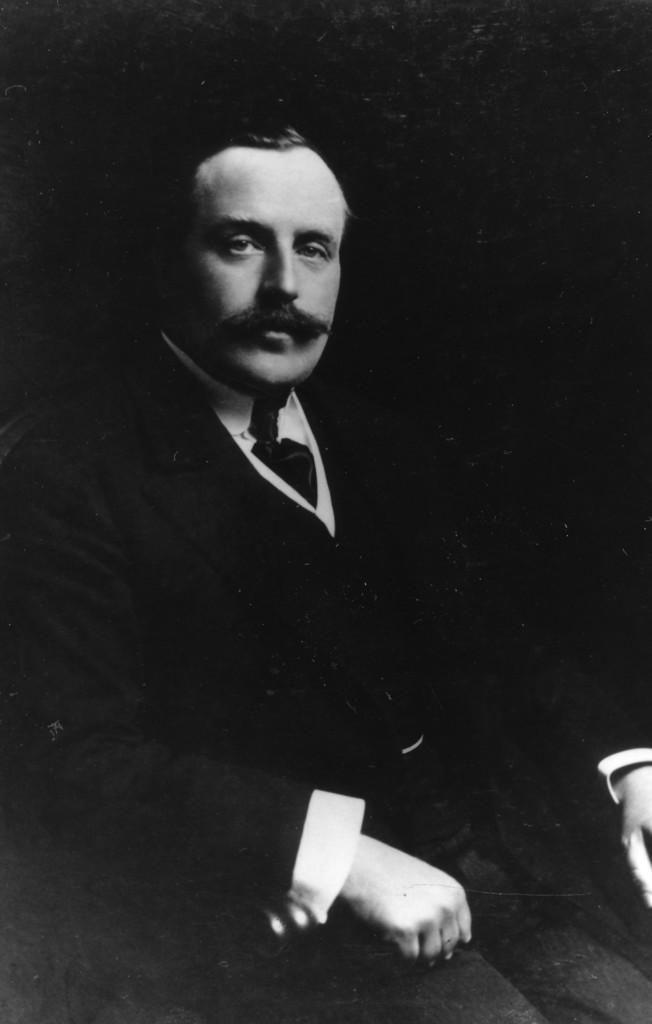What is the main subject of the image? There is a photo of a person in the image. Can you describe the background of the image? The background of the image is dark. How many books can be seen on the person's head in the image? There are no books visible in the image; it only features a photo of a person with a dark background. 